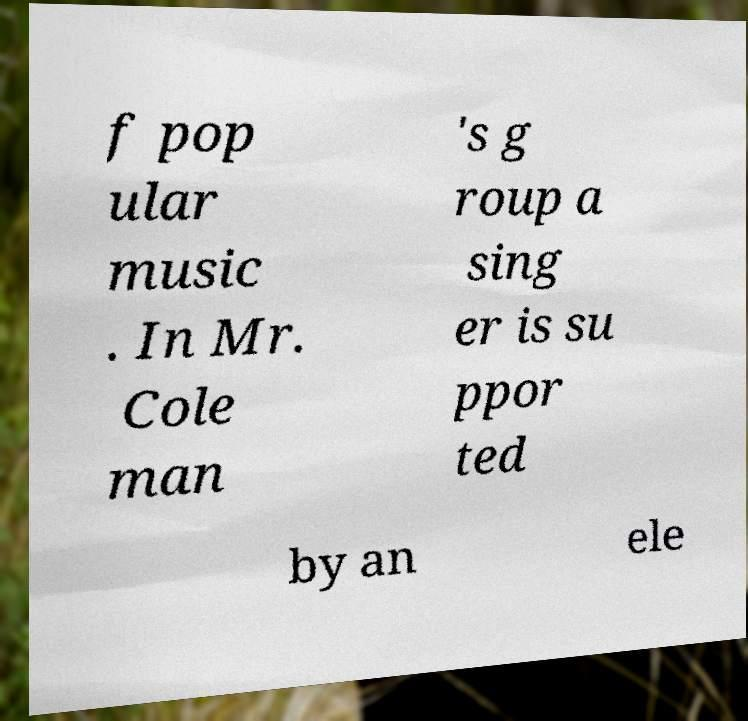There's text embedded in this image that I need extracted. Can you transcribe it verbatim? f pop ular music . In Mr. Cole man 's g roup a sing er is su ppor ted by an ele 